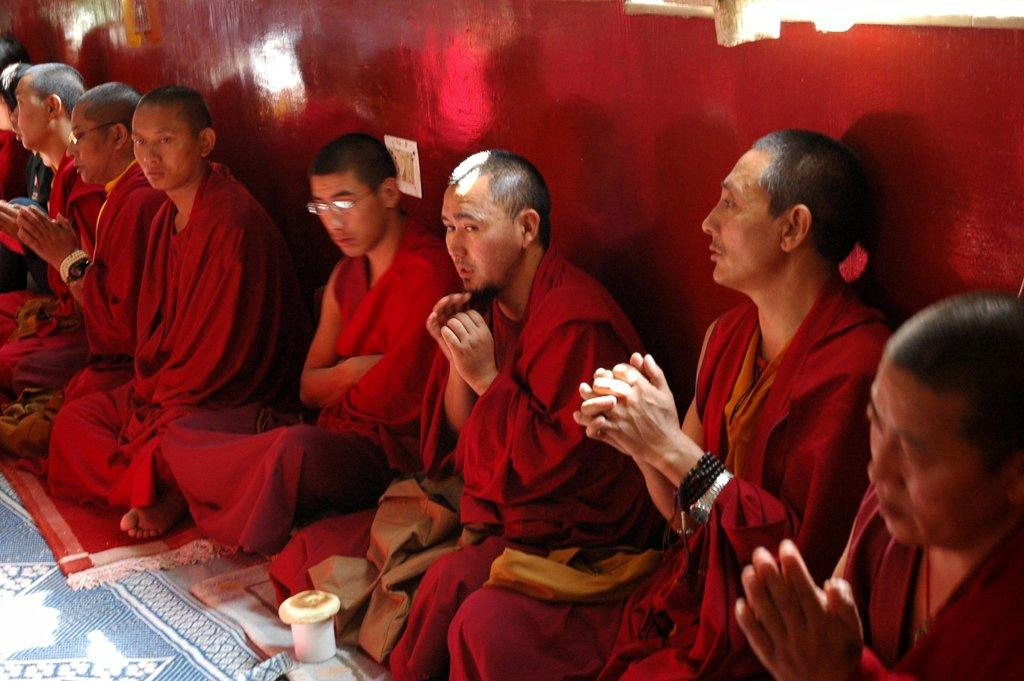What are the people in the image doing? The persons in the image are sitting. Where are the persons sitting in the image? The persons are sitting on the right side. What color are the clothes worn by the persons in the image? The persons are wearing red clothes. What can be seen in the background of the image? There is a wall in the background of the image. What type of finger food is the queen eating in the image? There is no queen or finger food present in the image. 